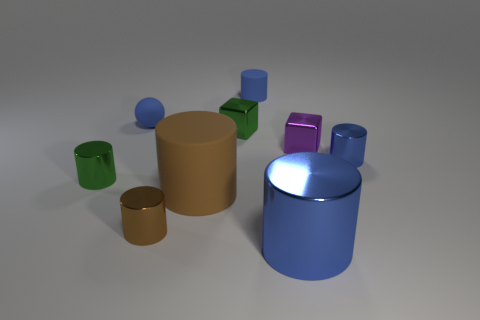Can you describe the lighting and shadows in the scene? The lighting in the image appears diffused, with soft shadows cast to the right of the objects, suggesting a light source coming from the left-hand side. 